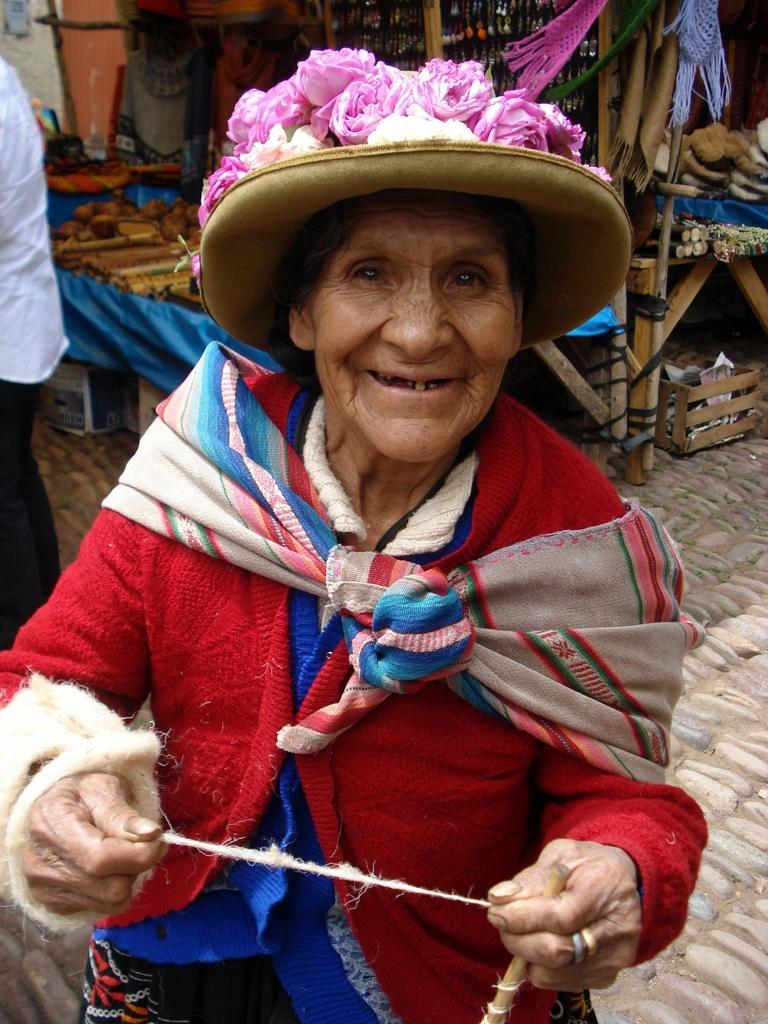How many people are in the image? There are two persons in the image. What is the lady holding in her hands? The lady is holding a rope and a stick. What can be seen on the table in the image? There are objects on the table. What is located under the table? There are boxes under the table. What type of polish is the lady applying to her stomach in the image? There is no indication in the image that the lady is applying any polish to her stomach, nor is there any polish visible in the image. 